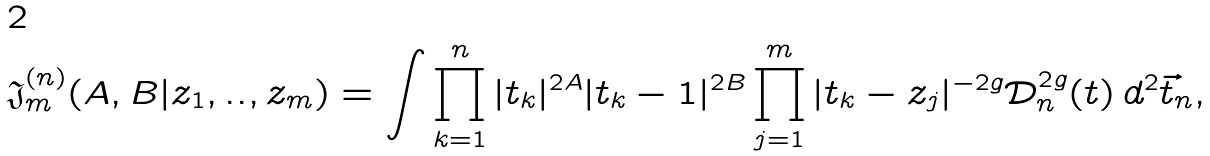<formula> <loc_0><loc_0><loc_500><loc_500>\mathfrak { J } _ { m } ^ { ( n ) } ( A , B | z _ { 1 } , . . , z _ { m } ) = \int \prod _ { k = 1 } ^ { n } | t _ { k } | ^ { 2 A } | t _ { k } - 1 | ^ { 2 B } \prod _ { j = 1 } ^ { m } | t _ { k } - z _ { j } | ^ { - 2 g } \mathcal { D } _ { n } ^ { 2 g } ( t ) \, d ^ { 2 } \vec { t } _ { n } ,</formula> 